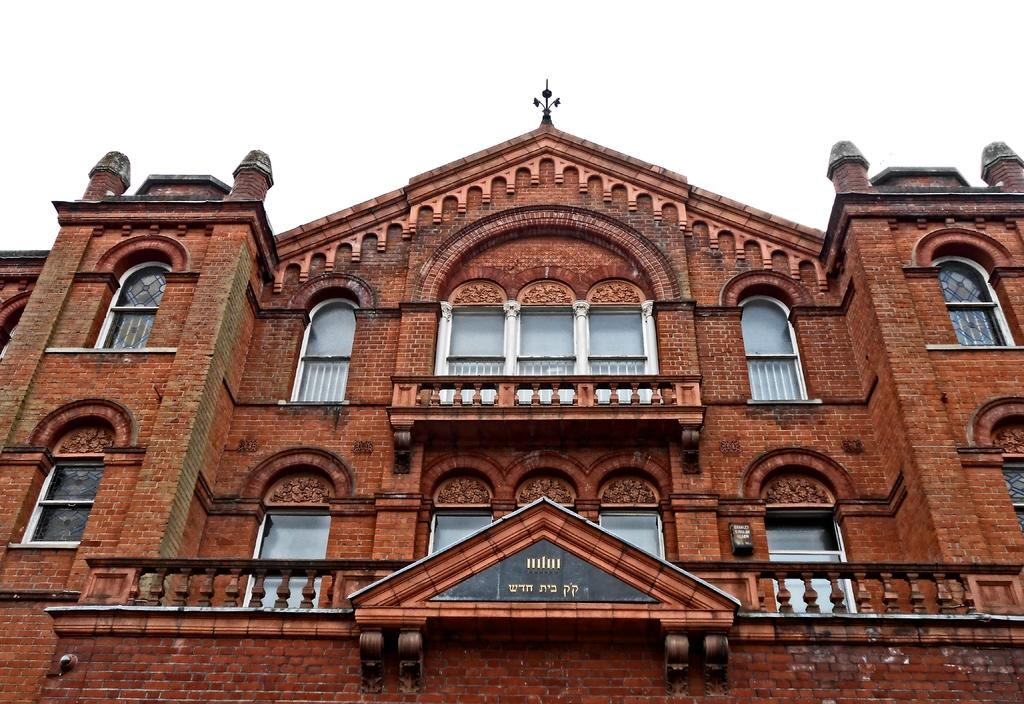What type of structure is present in the image? There is a building in the image. What can be seen in the background of the image? The sky is visible in the background of the image. What type of store is located on the left side of the building in the image? There is no store mentioned or visible in the image; only the building and sky are present. 